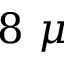<formula> <loc_0><loc_0><loc_500><loc_500>8 \mu</formula> 